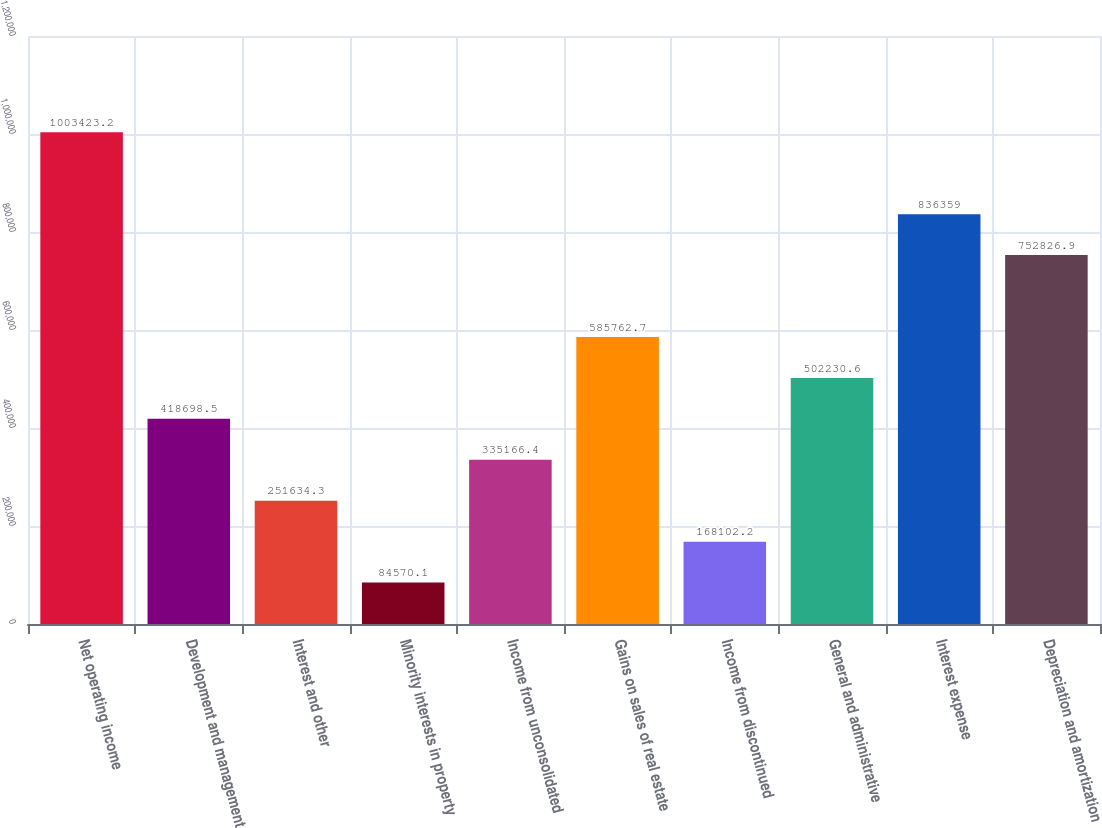Convert chart to OTSL. <chart><loc_0><loc_0><loc_500><loc_500><bar_chart><fcel>Net operating income<fcel>Development and management<fcel>Interest and other<fcel>Minority interests in property<fcel>Income from unconsolidated<fcel>Gains on sales of real estate<fcel>Income from discontinued<fcel>General and administrative<fcel>Interest expense<fcel>Depreciation and amortization<nl><fcel>1.00342e+06<fcel>418698<fcel>251634<fcel>84570.1<fcel>335166<fcel>585763<fcel>168102<fcel>502231<fcel>836359<fcel>752827<nl></chart> 